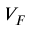Convert formula to latex. <formula><loc_0><loc_0><loc_500><loc_500>V _ { F }</formula> 